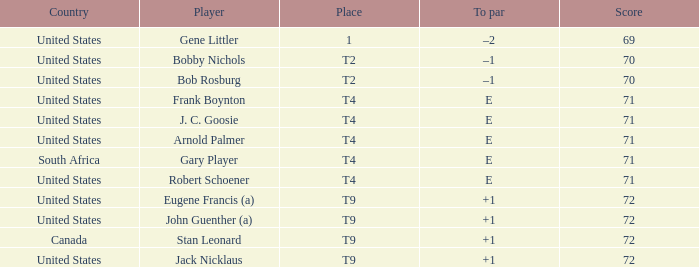Parse the table in full. {'header': ['Country', 'Player', 'Place', 'To par', 'Score'], 'rows': [['United States', 'Gene Littler', '1', '–2', '69'], ['United States', 'Bobby Nichols', 'T2', '–1', '70'], ['United States', 'Bob Rosburg', 'T2', '–1', '70'], ['United States', 'Frank Boynton', 'T4', 'E', '71'], ['United States', 'J. C. Goosie', 'T4', 'E', '71'], ['United States', 'Arnold Palmer', 'T4', 'E', '71'], ['South Africa', 'Gary Player', 'T4', 'E', '71'], ['United States', 'Robert Schoener', 'T4', 'E', '71'], ['United States', 'Eugene Francis (a)', 'T9', '+1', '72'], ['United States', 'John Guenther (a)', 'T9', '+1', '72'], ['Canada', 'Stan Leonard', 'T9', '+1', '72'], ['United States', 'Jack Nicklaus', 'T9', '+1', '72']]} What is To Par, when Country is "United States", when Place is "T4", and when Player is "Arnold Palmer"? E. 